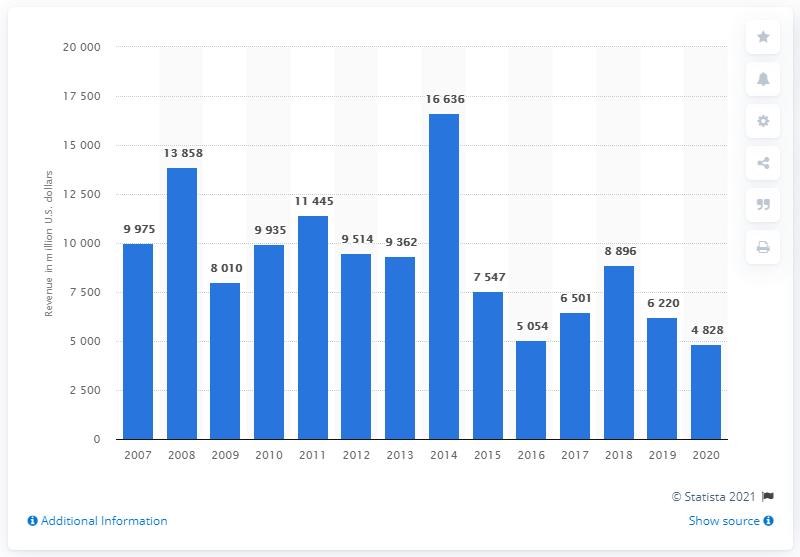Indicate a few pertinent items in this graphic. Devon Energy's revenue in 2020 was 4,828. In the year prior to the most recent year for which data is available, Devon Energy's revenue was approximately 6,220. 